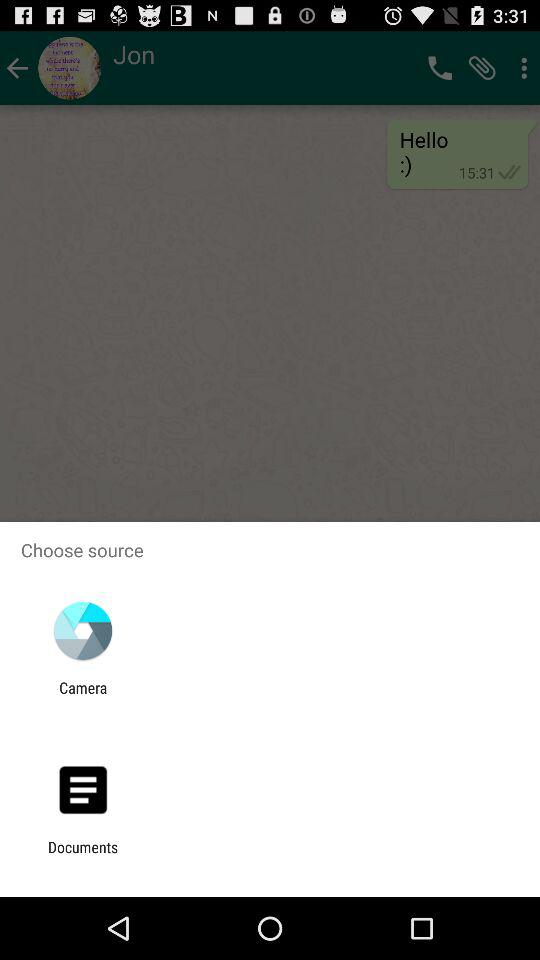What are the options to choose a source from? The options are "Camera" and "Documents". 